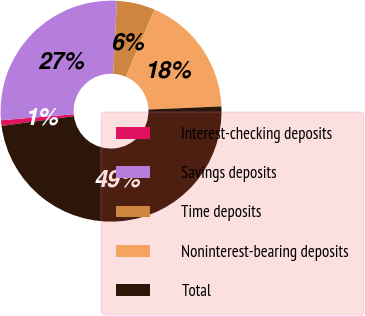Convert chart to OTSL. <chart><loc_0><loc_0><loc_500><loc_500><pie_chart><fcel>Interest-checking deposits<fcel>Savings deposits<fcel>Time deposits<fcel>Noninterest-bearing deposits<fcel>Total<nl><fcel>0.82%<fcel>27.17%<fcel>5.59%<fcel>17.88%<fcel>48.55%<nl></chart> 